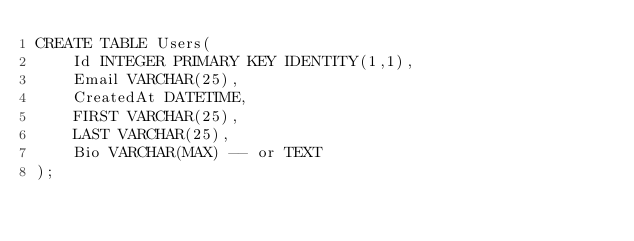<code> <loc_0><loc_0><loc_500><loc_500><_SQL_>CREATE TABLE Users(
	Id INTEGER PRIMARY KEY IDENTITY(1,1),
	Email VARCHAR(25),
	CreatedAt DATETIME,
	FIRST VARCHAR(25),
	LAST VARCHAR(25),
	Bio VARCHAR(MAX) -- or TEXT
);</code> 